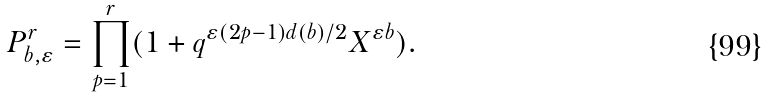Convert formula to latex. <formula><loc_0><loc_0><loc_500><loc_500>P ^ { r } _ { b , \varepsilon } = \prod _ { p = 1 } ^ { r } ( 1 + q ^ { \varepsilon ( 2 p - 1 ) d ( b ) / 2 } X ^ { \varepsilon b } ) .</formula> 